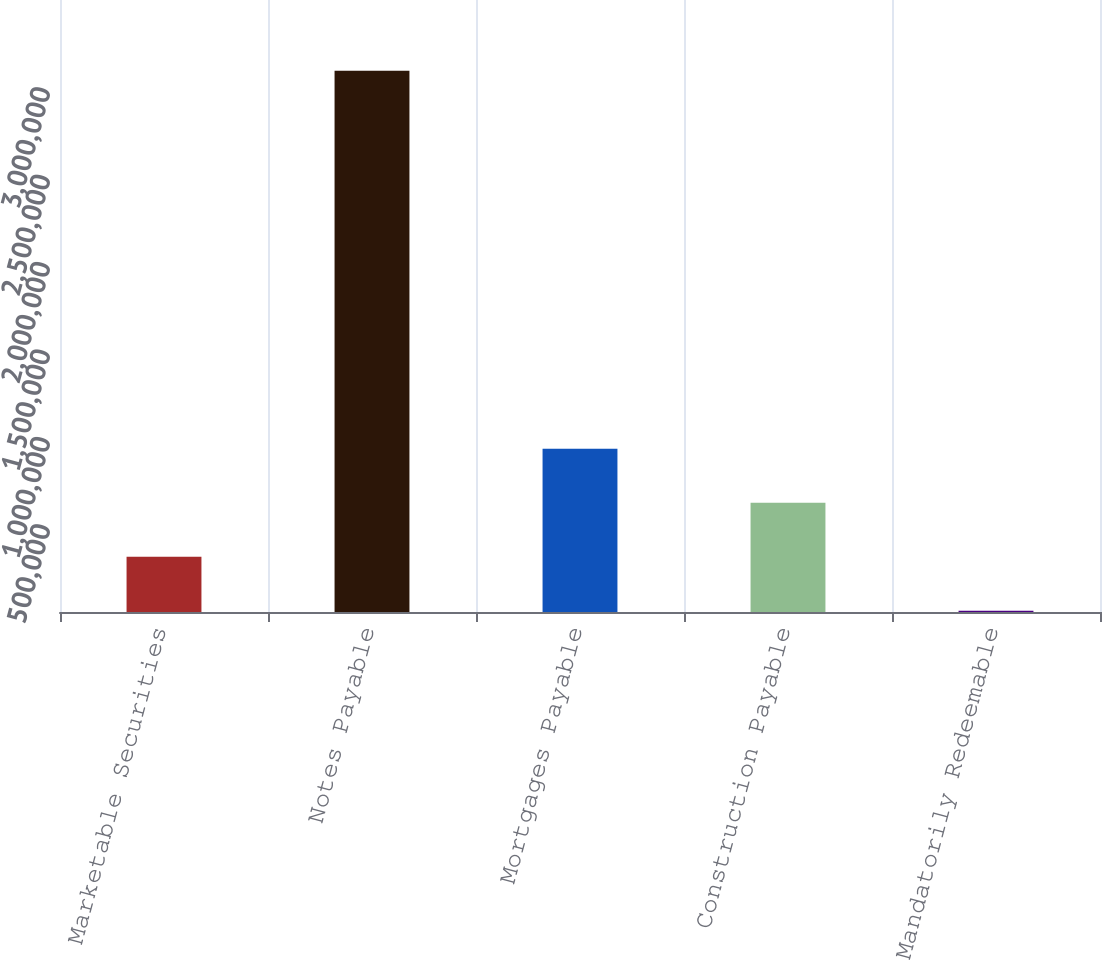<chart> <loc_0><loc_0><loc_500><loc_500><bar_chart><fcel>Marketable Securities<fcel>Notes Payable<fcel>Mortgages Payable<fcel>Construction Payable<fcel>Mandatorily Redeemable<nl><fcel>315369<fcel>3.095e+06<fcel>933066<fcel>624218<fcel>6521<nl></chart> 